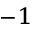Convert formula to latex. <formula><loc_0><loc_0><loc_500><loc_500>^ { - 1 }</formula> 